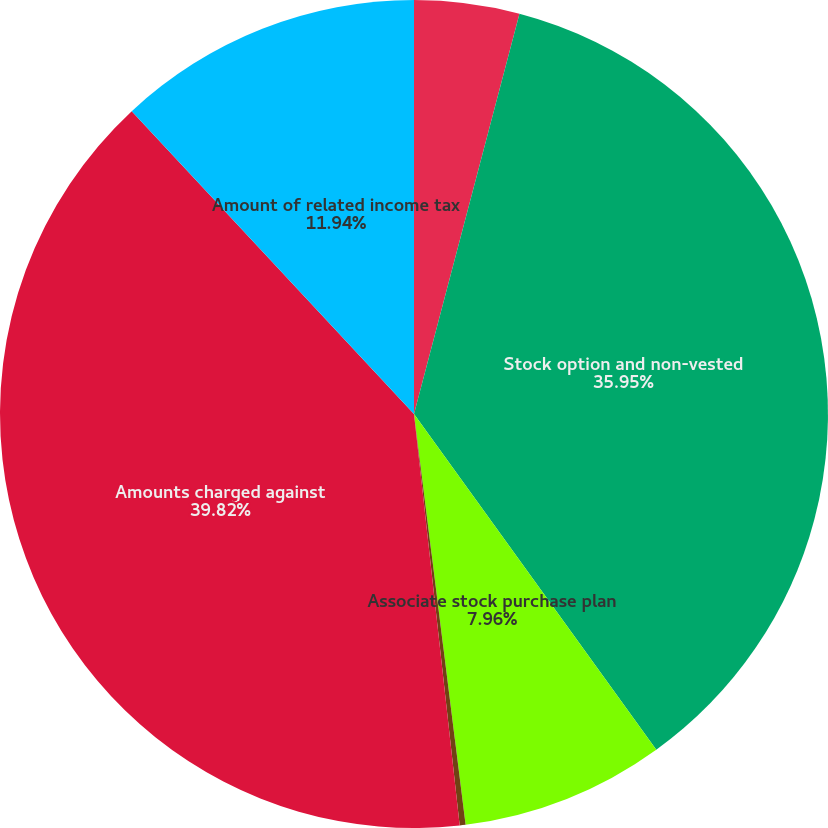<chart> <loc_0><loc_0><loc_500><loc_500><pie_chart><fcel>(In thousands)<fcel>Stock option and non-vested<fcel>Associate stock purchase plan<fcel>Amounts capitalized in<fcel>Amounts charged against<fcel>Amount of related income tax<nl><fcel>4.1%<fcel>35.95%<fcel>7.96%<fcel>0.23%<fcel>39.82%<fcel>11.94%<nl></chart> 